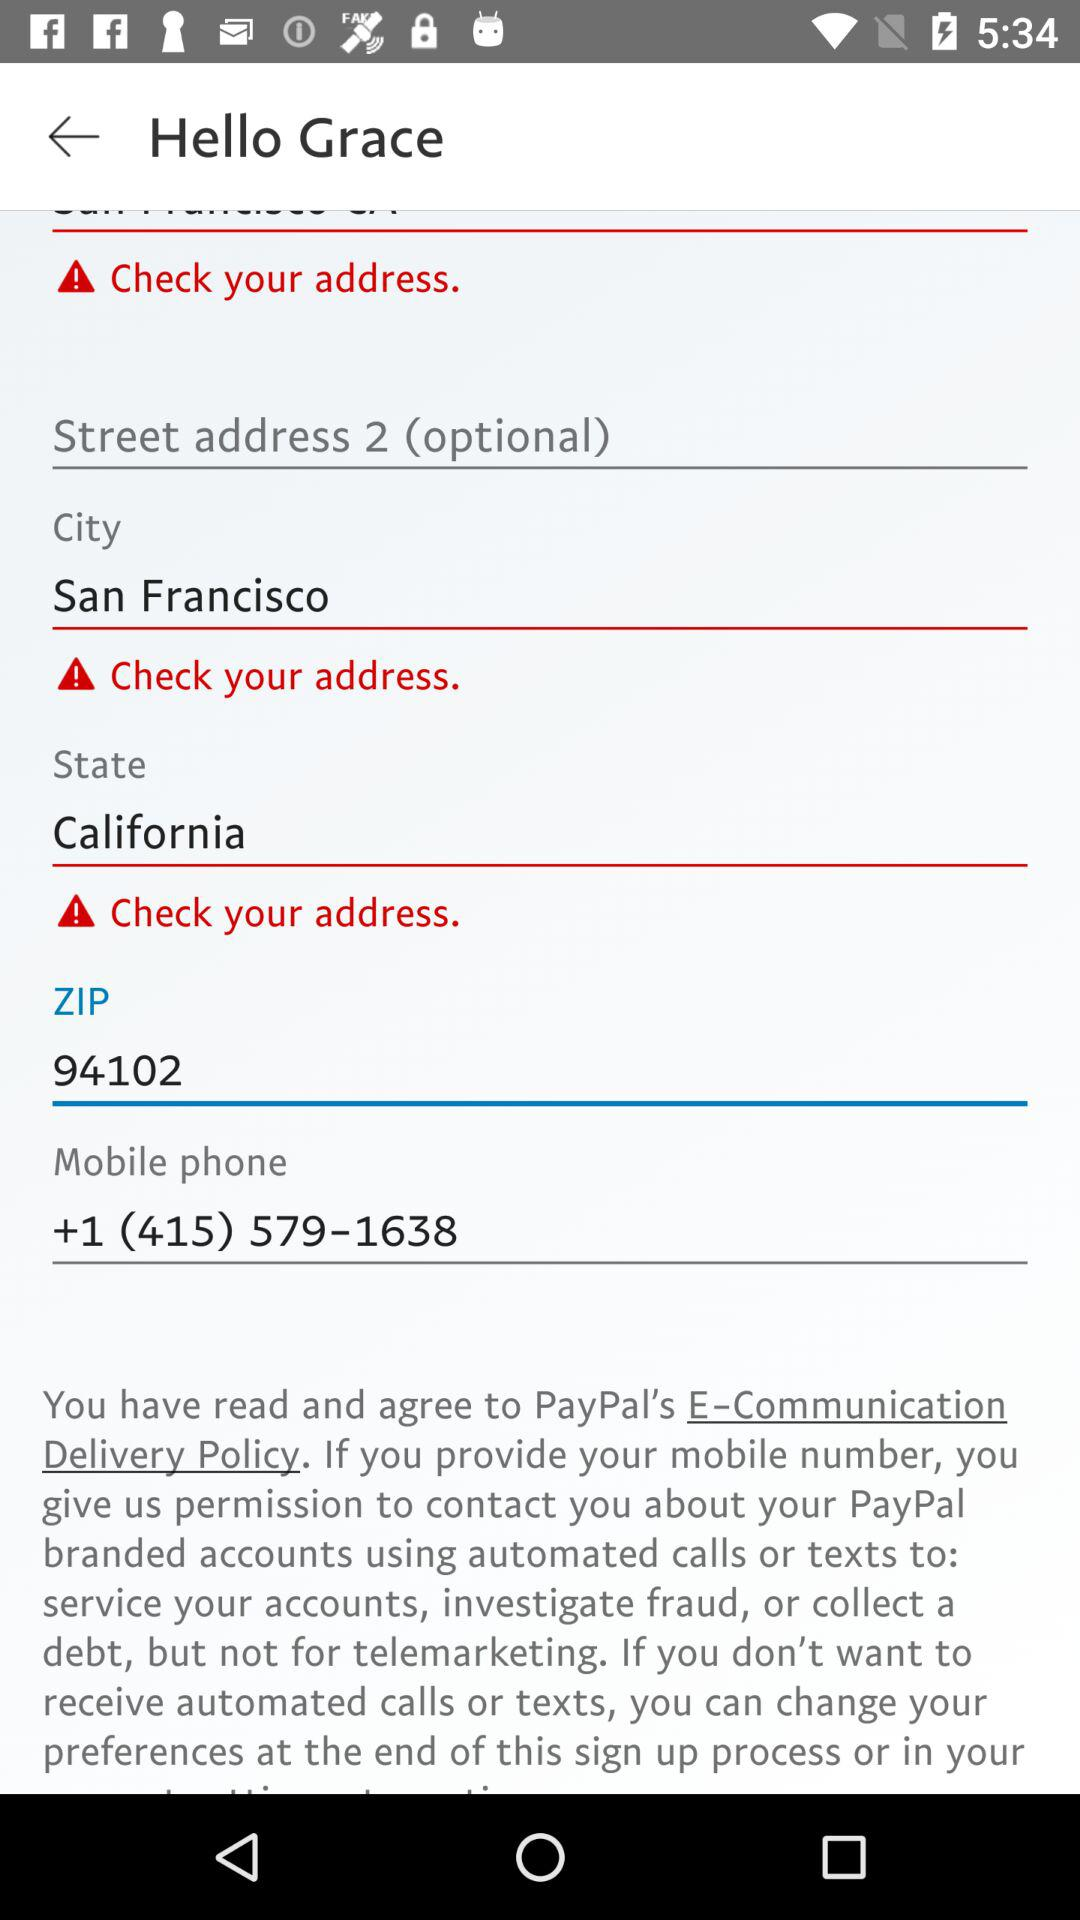How many text inputs have an exclamation mark next to them?
Answer the question using a single word or phrase. 3 